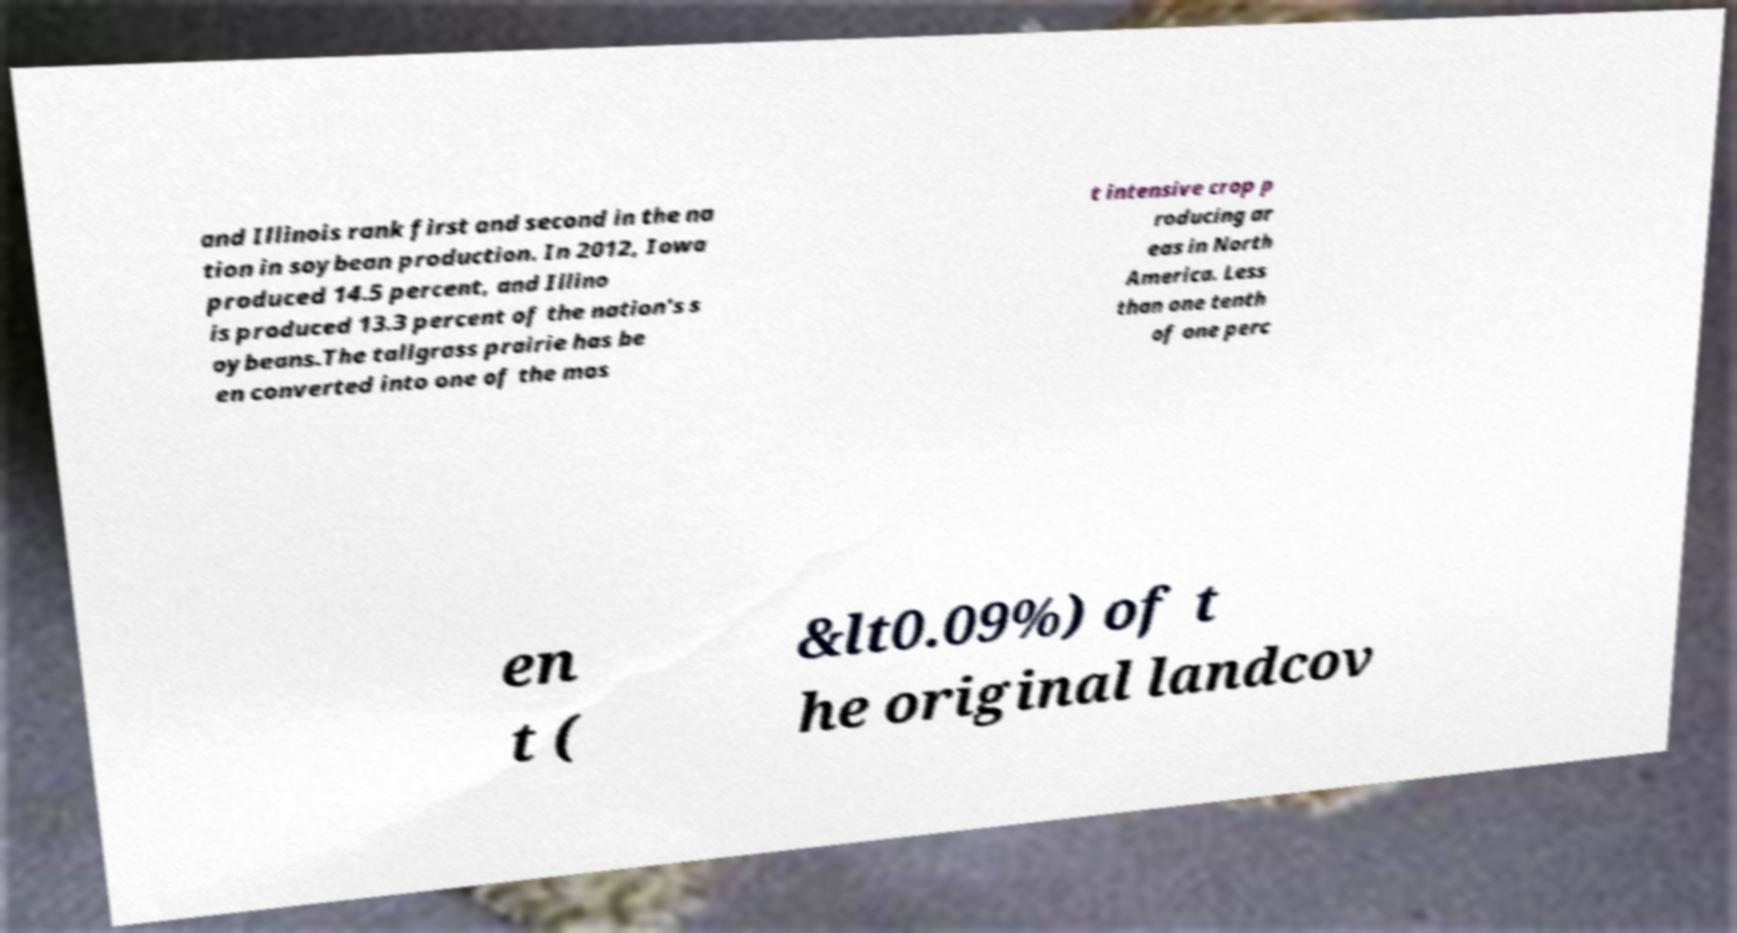Can you accurately transcribe the text from the provided image for me? and Illinois rank first and second in the na tion in soybean production. In 2012, Iowa produced 14.5 percent, and Illino is produced 13.3 percent of the nation's s oybeans.The tallgrass prairie has be en converted into one of the mos t intensive crop p roducing ar eas in North America. Less than one tenth of one perc en t ( &lt0.09%) of t he original landcov 